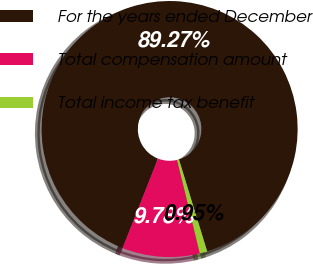Convert chart to OTSL. <chart><loc_0><loc_0><loc_500><loc_500><pie_chart><fcel>For the years ended December<fcel>Total compensation amount<fcel>Total income tax benefit<nl><fcel>89.27%<fcel>9.78%<fcel>0.95%<nl></chart> 